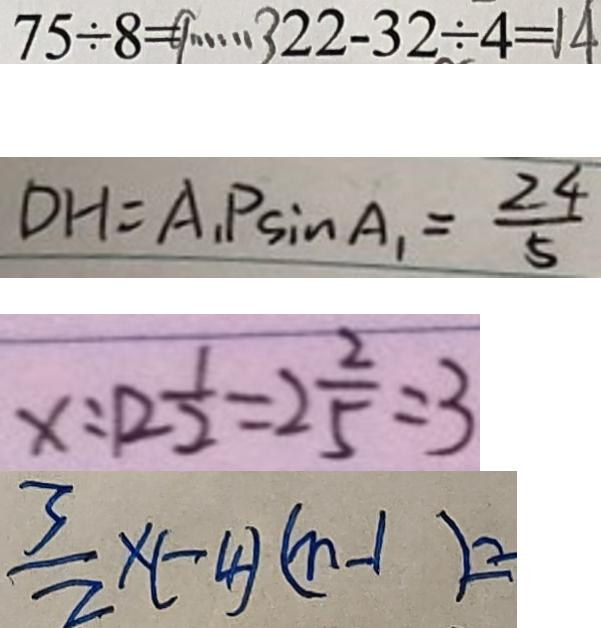Convert formula to latex. <formula><loc_0><loc_0><loc_500><loc_500>7 5 \div 8 = 9 \cdots 3 2 2 - 3 2 \div 4 = 1 4 
 D H = A _ { 1 } P \sin A _ { 1 } = \frac { 2 4 } { 5 } 
 x : 1 2 \frac { 1 } { 2 } = 2 \frac { 2 } { 5 } : 3 
 \frac { 3 } { 2 } \times ( - 4 ) ( n - 1 ) =</formula> 